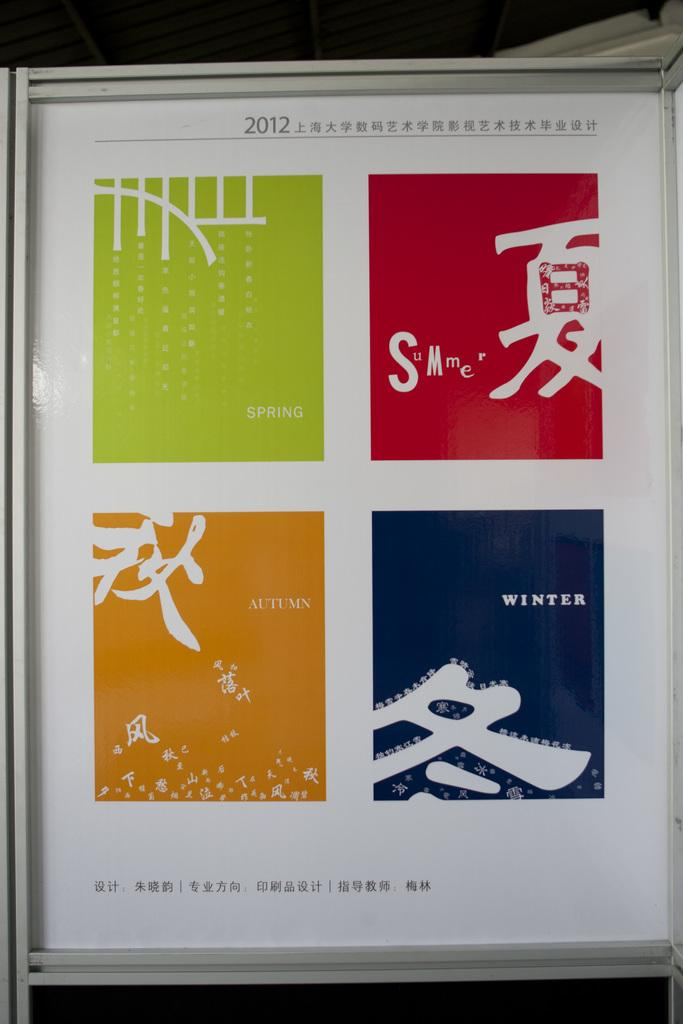<image>
Write a terse but informative summary of the picture. Four posters in a frame representing Summer, Spring, Autumn and Winter. 